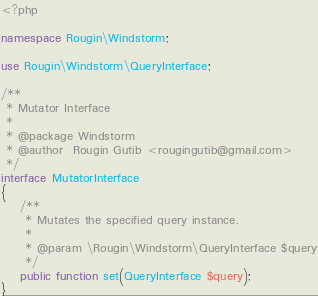Convert code to text. <code><loc_0><loc_0><loc_500><loc_500><_PHP_><?php

namespace Rougin\Windstorm;

use Rougin\Windstorm\QueryInterface;

/**
 * Mutator Interface
 *
 * @package Windstorm
 * @author  Rougin Gutib <rougingutib@gmail.com>
 */
interface MutatorInterface
{
    /**
     * Mutates the specified query instance.
     *
     * @param \Rougin\Windstorm\QueryInterface $query
     */
    public function set(QueryInterface $query);
}
</code> 